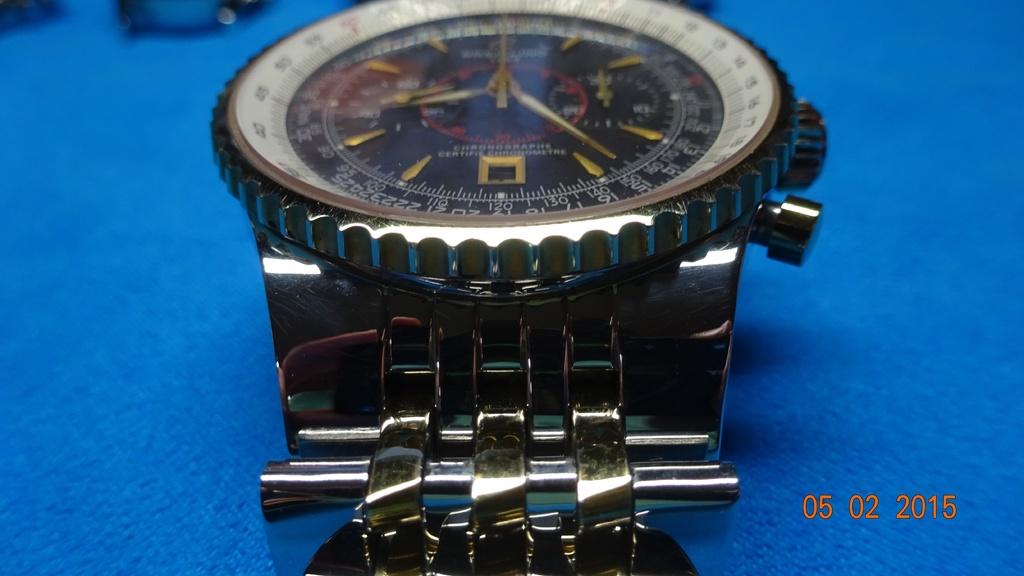Is the date 05 02 2015  written on the lower right ?
Offer a terse response. Yes. 